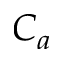Convert formula to latex. <formula><loc_0><loc_0><loc_500><loc_500>C _ { a }</formula> 